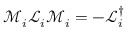<formula> <loc_0><loc_0><loc_500><loc_500>\mathcal { M } _ { i } \mathcal { L } _ { i } \mathcal { M } _ { i } = - \mathcal { L } _ { i } ^ { \dagger }</formula> 